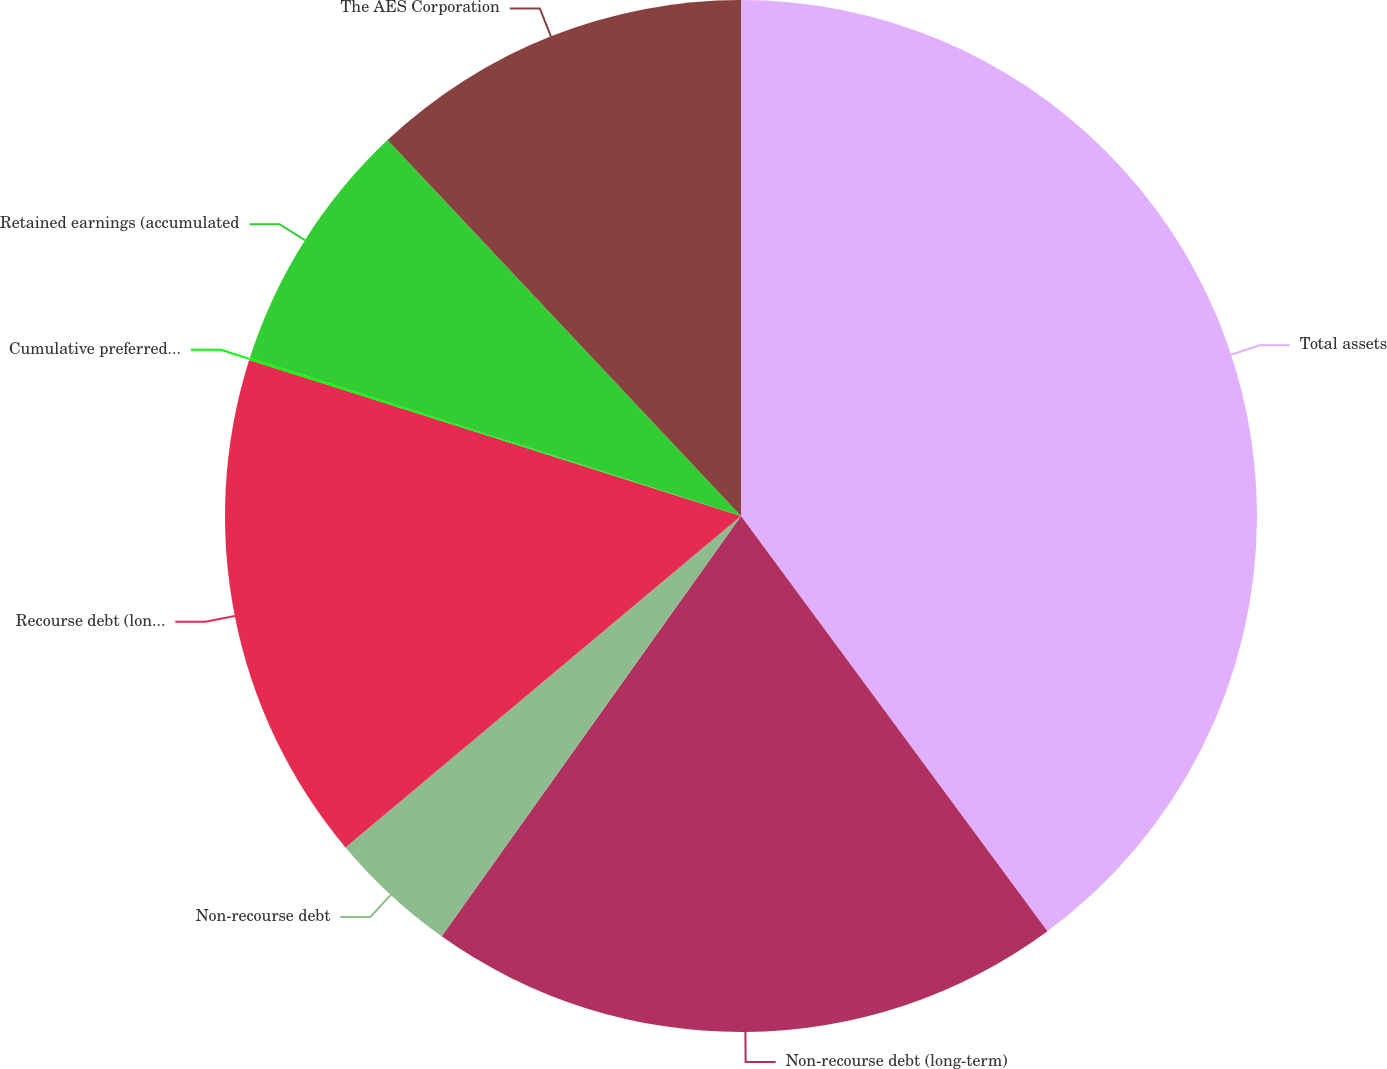Convert chart. <chart><loc_0><loc_0><loc_500><loc_500><pie_chart><fcel>Total assets<fcel>Non-recourse debt (long-term)<fcel>Non-recourse debt<fcel>Recourse debt (long-term)<fcel>Cumulative preferred stock of<fcel>Retained earnings (accumulated<fcel>The AES Corporation<nl><fcel>39.88%<fcel>19.97%<fcel>4.05%<fcel>15.99%<fcel>0.07%<fcel>8.03%<fcel>12.01%<nl></chart> 